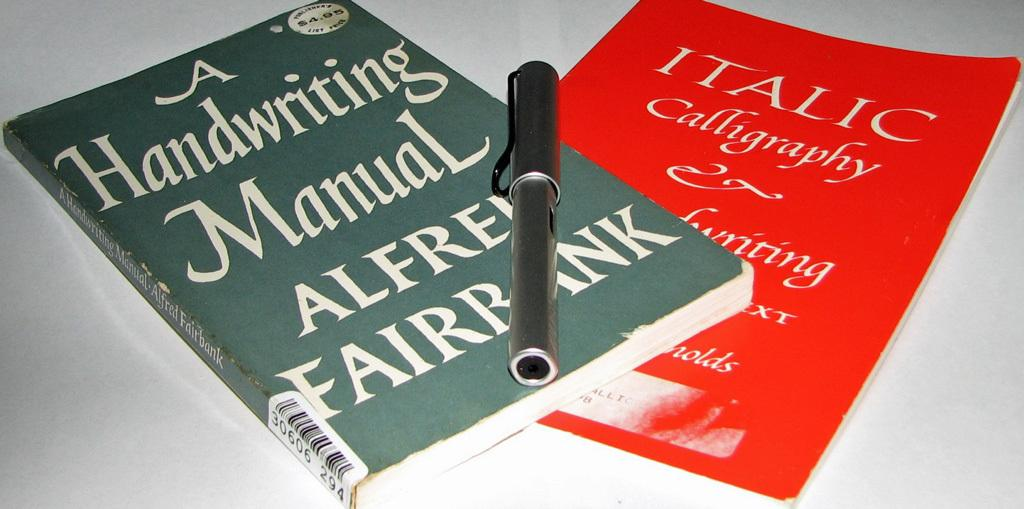<image>
Create a compact narrative representing the image presented. A book titled "A Handwriting Manual" is on top of a red book. 